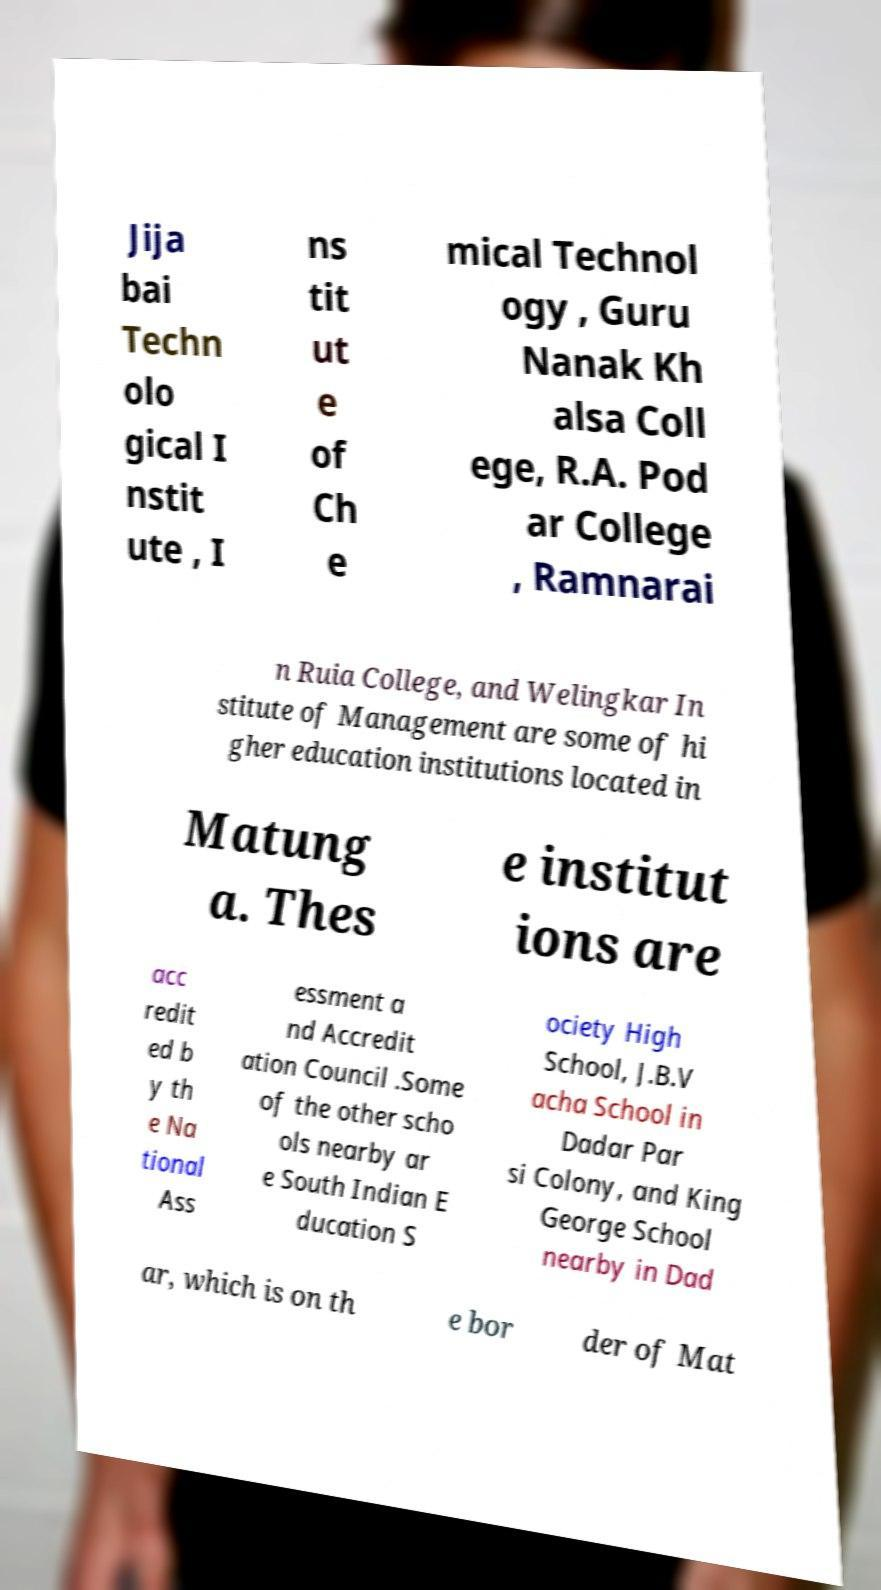Can you read and provide the text displayed in the image?This photo seems to have some interesting text. Can you extract and type it out for me? Jija bai Techn olo gical I nstit ute , I ns tit ut e of Ch e mical Technol ogy , Guru Nanak Kh alsa Coll ege, R.A. Pod ar College , Ramnarai n Ruia College, and Welingkar In stitute of Management are some of hi gher education institutions located in Matung a. Thes e institut ions are acc redit ed b y th e Na tional Ass essment a nd Accredit ation Council .Some of the other scho ols nearby ar e South Indian E ducation S ociety High School, J.B.V acha School in Dadar Par si Colony, and King George School nearby in Dad ar, which is on th e bor der of Mat 